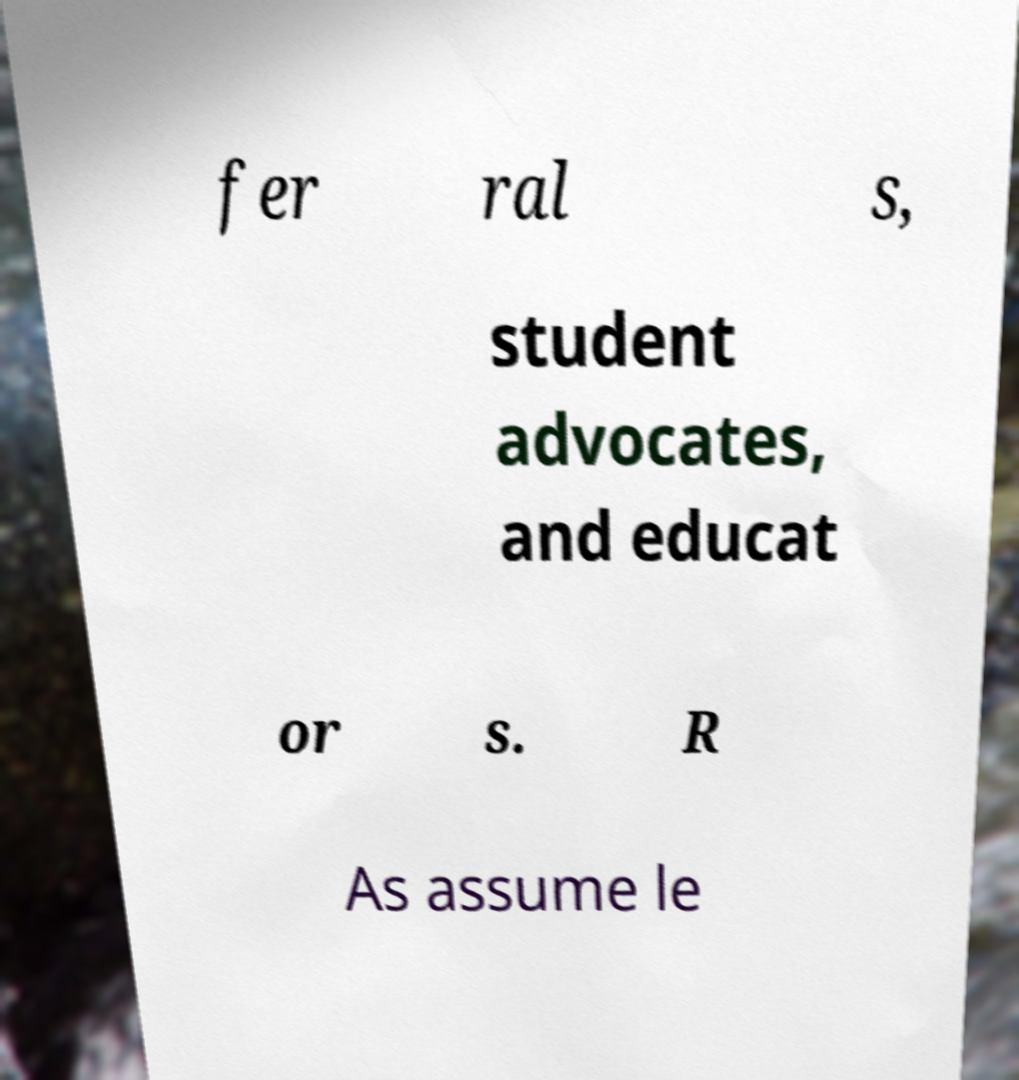Can you read and provide the text displayed in the image?This photo seems to have some interesting text. Can you extract and type it out for me? fer ral s, student advocates, and educat or s. R As assume le 